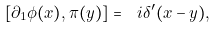<formula> <loc_0><loc_0><loc_500><loc_500>[ \partial _ { 1 } \phi ( x ) , \pi ( y ) ] = \ i \delta ^ { \prime } ( x - y ) ,</formula> 